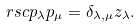Convert formula to latex. <formula><loc_0><loc_0><loc_500><loc_500>\ r s c { p _ { \lambda } } { p _ { \mu } } = \delta _ { \lambda , \mu } z _ { \lambda } .</formula> 